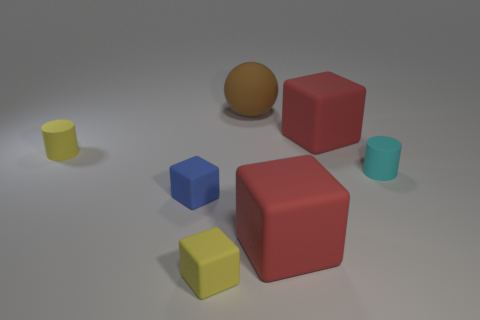Subtract 1 cubes. How many cubes are left? 3 Add 2 yellow shiny things. How many objects exist? 9 Subtract all cylinders. How many objects are left? 5 Subtract all big red matte blocks. Subtract all large cubes. How many objects are left? 3 Add 1 blue matte cubes. How many blue matte cubes are left? 2 Add 1 small brown cylinders. How many small brown cylinders exist? 1 Subtract 0 purple cylinders. How many objects are left? 7 